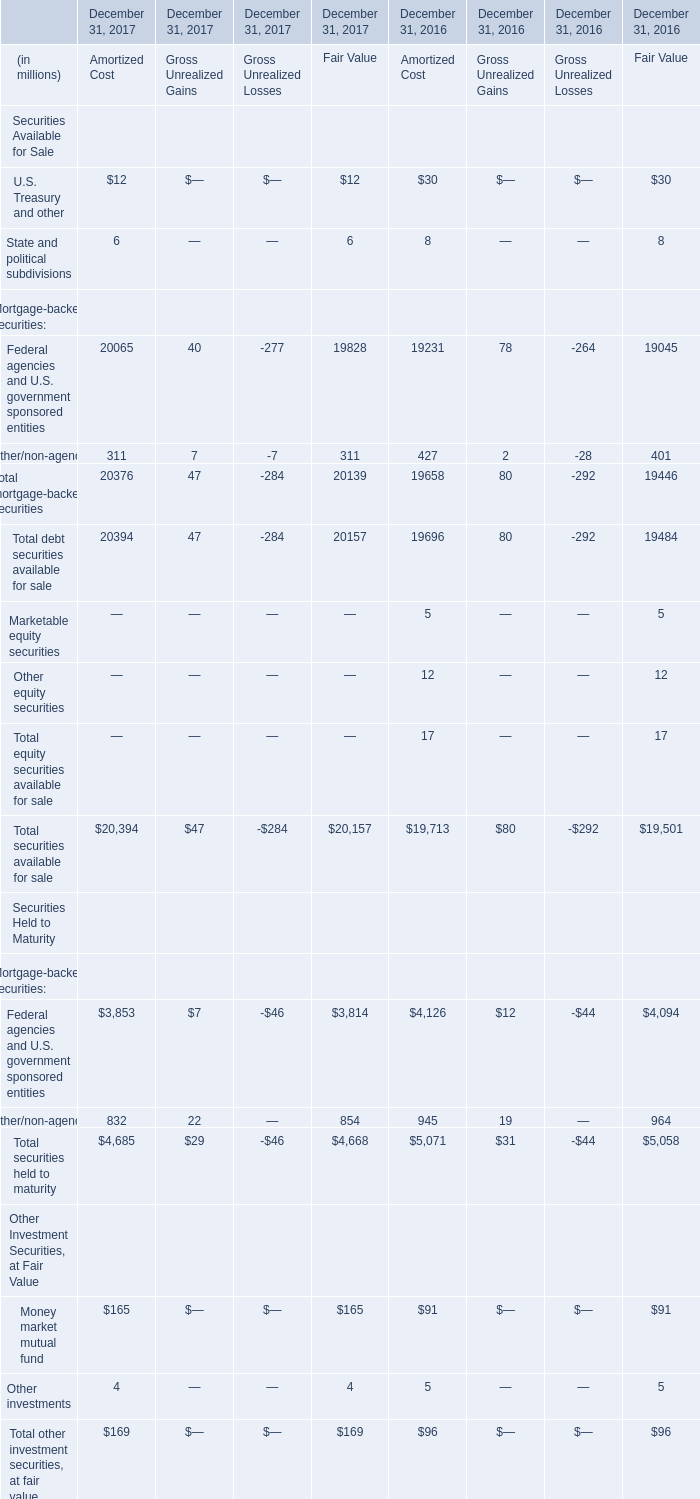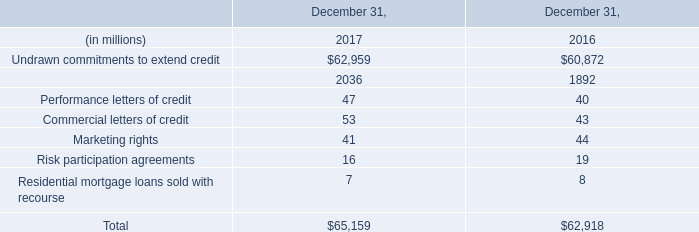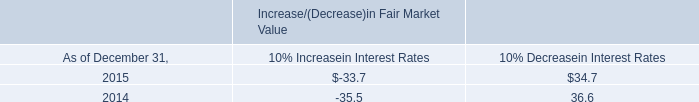In the year with the most Total debt securities available for sale for Fair Value, what is the growth rate of Total securities available for sale for Fair Value? 
Computations: ((20157 - 19501) / 19501)
Answer: 0.03364. Which year is Total debt securities available for sale for Fair Value the most? 
Answer: 2017. 